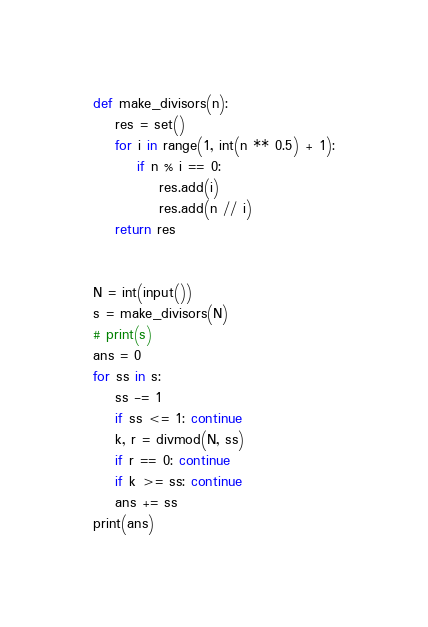Convert code to text. <code><loc_0><loc_0><loc_500><loc_500><_Python_>def make_divisors(n):
    res = set()
    for i in range(1, int(n ** 0.5) + 1):
        if n % i == 0:
            res.add(i)
            res.add(n // i)
    return res


N = int(input())
s = make_divisors(N)
# print(s)
ans = 0
for ss in s:
    ss -= 1
    if ss <= 1: continue
    k, r = divmod(N, ss)
    if r == 0: continue
    if k >= ss: continue
    ans += ss
print(ans)
</code> 